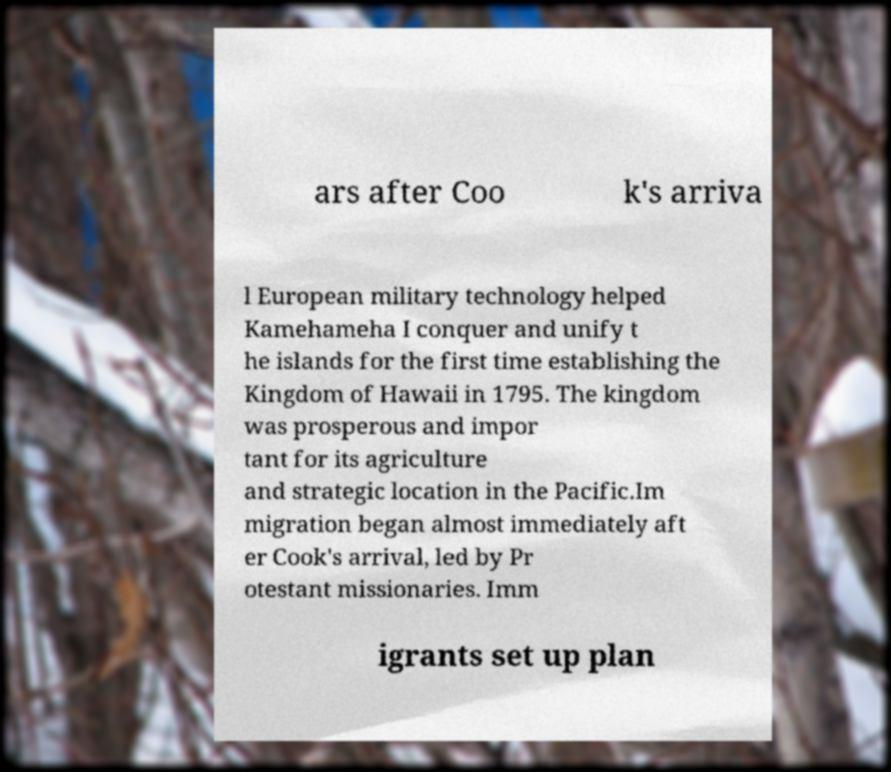Can you accurately transcribe the text from the provided image for me? ars after Coo k's arriva l European military technology helped Kamehameha I conquer and unify t he islands for the first time establishing the Kingdom of Hawaii in 1795. The kingdom was prosperous and impor tant for its agriculture and strategic location in the Pacific.Im migration began almost immediately aft er Cook's arrival, led by Pr otestant missionaries. Imm igrants set up plan 